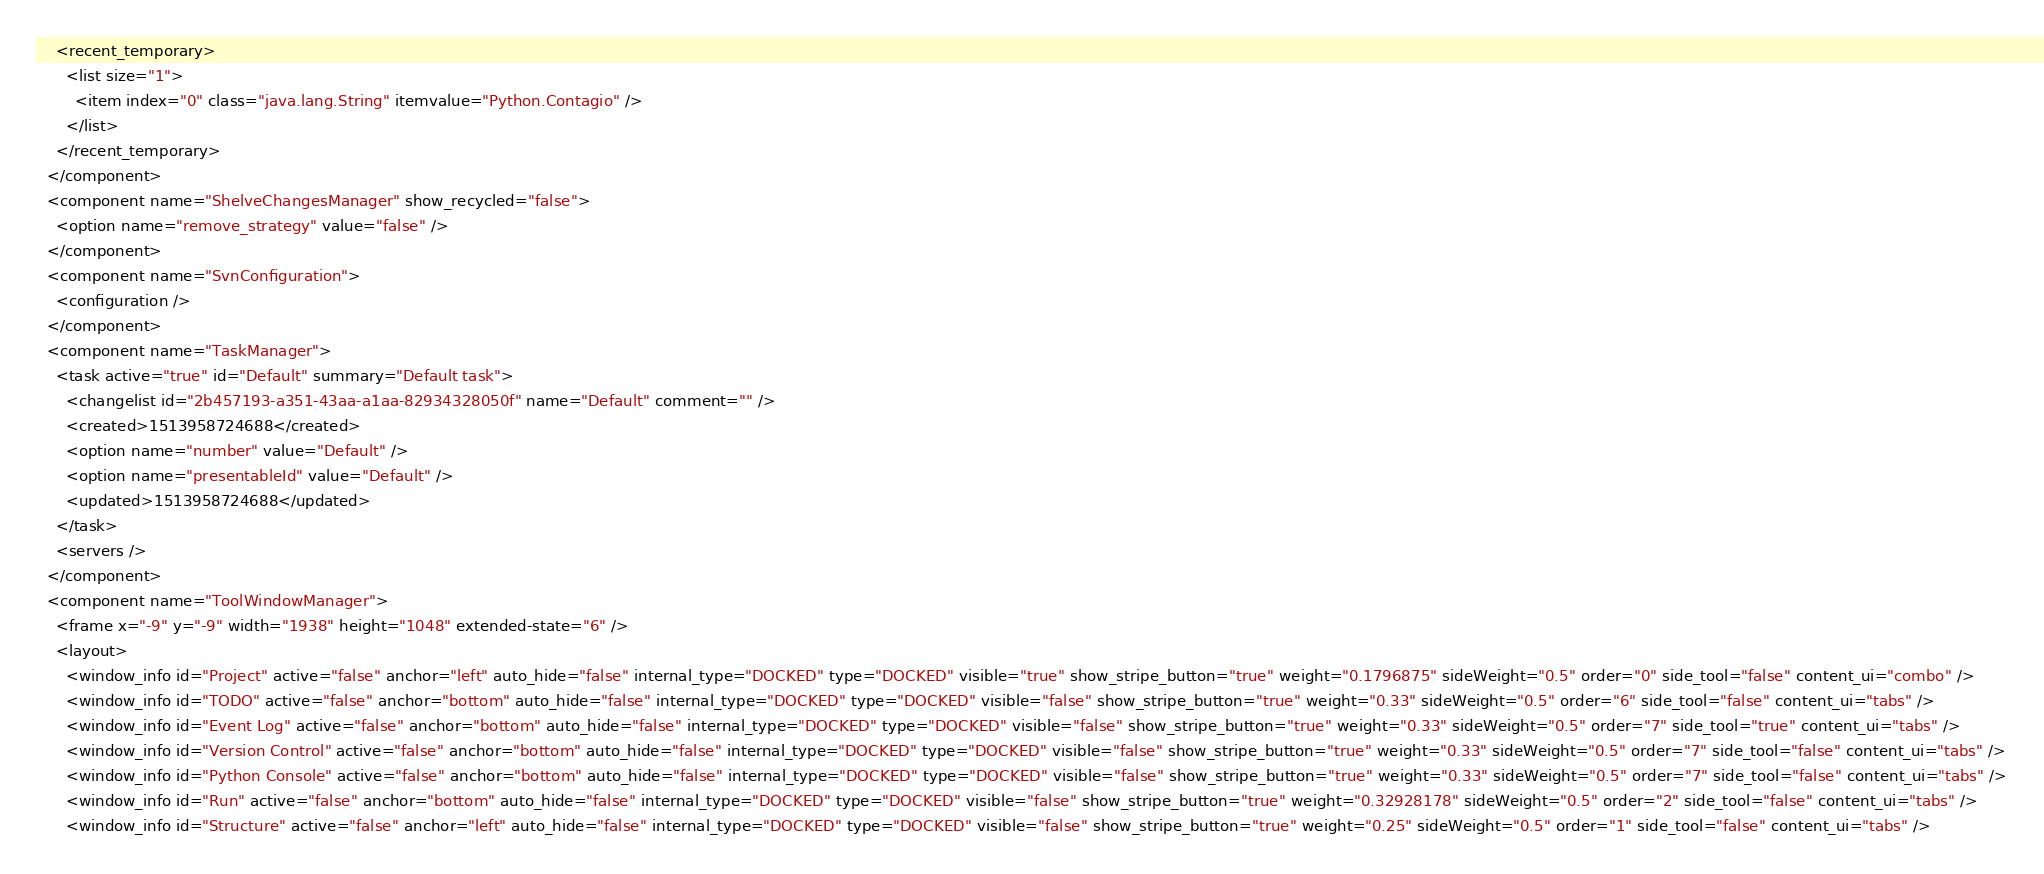Convert code to text. <code><loc_0><loc_0><loc_500><loc_500><_XML_>    <recent_temporary>
      <list size="1">
        <item index="0" class="java.lang.String" itemvalue="Python.Contagio" />
      </list>
    </recent_temporary>
  </component>
  <component name="ShelveChangesManager" show_recycled="false">
    <option name="remove_strategy" value="false" />
  </component>
  <component name="SvnConfiguration">
    <configuration />
  </component>
  <component name="TaskManager">
    <task active="true" id="Default" summary="Default task">
      <changelist id="2b457193-a351-43aa-a1aa-82934328050f" name="Default" comment="" />
      <created>1513958724688</created>
      <option name="number" value="Default" />
      <option name="presentableId" value="Default" />
      <updated>1513958724688</updated>
    </task>
    <servers />
  </component>
  <component name="ToolWindowManager">
    <frame x="-9" y="-9" width="1938" height="1048" extended-state="6" />
    <layout>
      <window_info id="Project" active="false" anchor="left" auto_hide="false" internal_type="DOCKED" type="DOCKED" visible="true" show_stripe_button="true" weight="0.1796875" sideWeight="0.5" order="0" side_tool="false" content_ui="combo" />
      <window_info id="TODO" active="false" anchor="bottom" auto_hide="false" internal_type="DOCKED" type="DOCKED" visible="false" show_stripe_button="true" weight="0.33" sideWeight="0.5" order="6" side_tool="false" content_ui="tabs" />
      <window_info id="Event Log" active="false" anchor="bottom" auto_hide="false" internal_type="DOCKED" type="DOCKED" visible="false" show_stripe_button="true" weight="0.33" sideWeight="0.5" order="7" side_tool="true" content_ui="tabs" />
      <window_info id="Version Control" active="false" anchor="bottom" auto_hide="false" internal_type="DOCKED" type="DOCKED" visible="false" show_stripe_button="true" weight="0.33" sideWeight="0.5" order="7" side_tool="false" content_ui="tabs" />
      <window_info id="Python Console" active="false" anchor="bottom" auto_hide="false" internal_type="DOCKED" type="DOCKED" visible="false" show_stripe_button="true" weight="0.33" sideWeight="0.5" order="7" side_tool="false" content_ui="tabs" />
      <window_info id="Run" active="false" anchor="bottom" auto_hide="false" internal_type="DOCKED" type="DOCKED" visible="false" show_stripe_button="true" weight="0.32928178" sideWeight="0.5" order="2" side_tool="false" content_ui="tabs" />
      <window_info id="Structure" active="false" anchor="left" auto_hide="false" internal_type="DOCKED" type="DOCKED" visible="false" show_stripe_button="true" weight="0.25" sideWeight="0.5" order="1" side_tool="false" content_ui="tabs" /></code> 